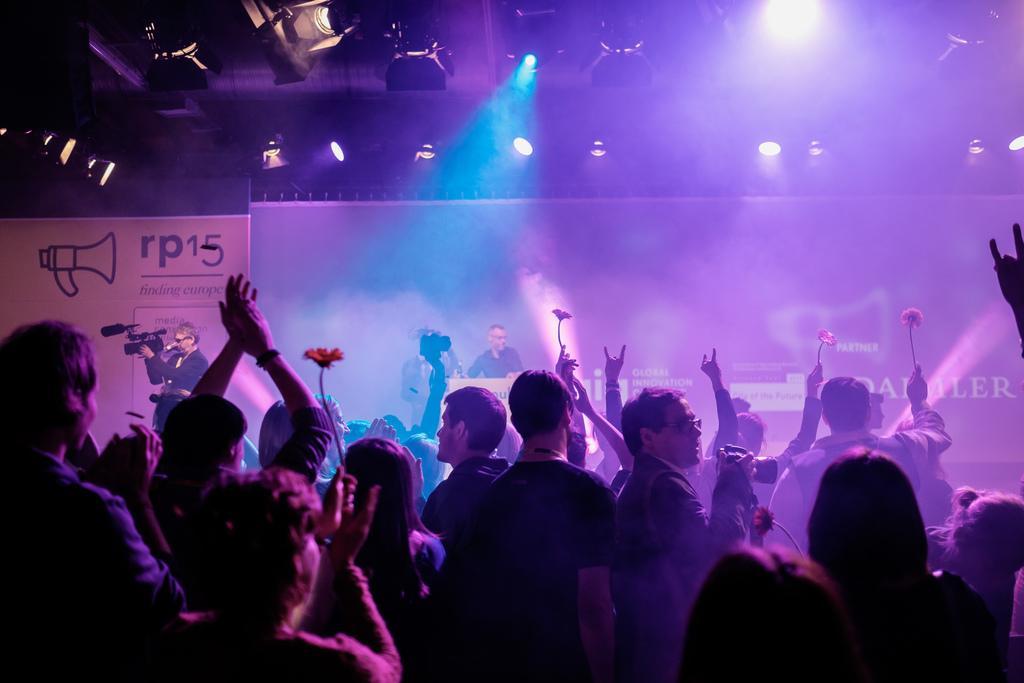How would you summarize this image in a sentence or two? In the image there are many people standing. There are few people holding flowers in their hands. In the background there is a man standing behind the podium and also there is another man standing and holding a video camera in his hands. Behind them there is a poster and also there is a screen. At the top of the image there are lights.  